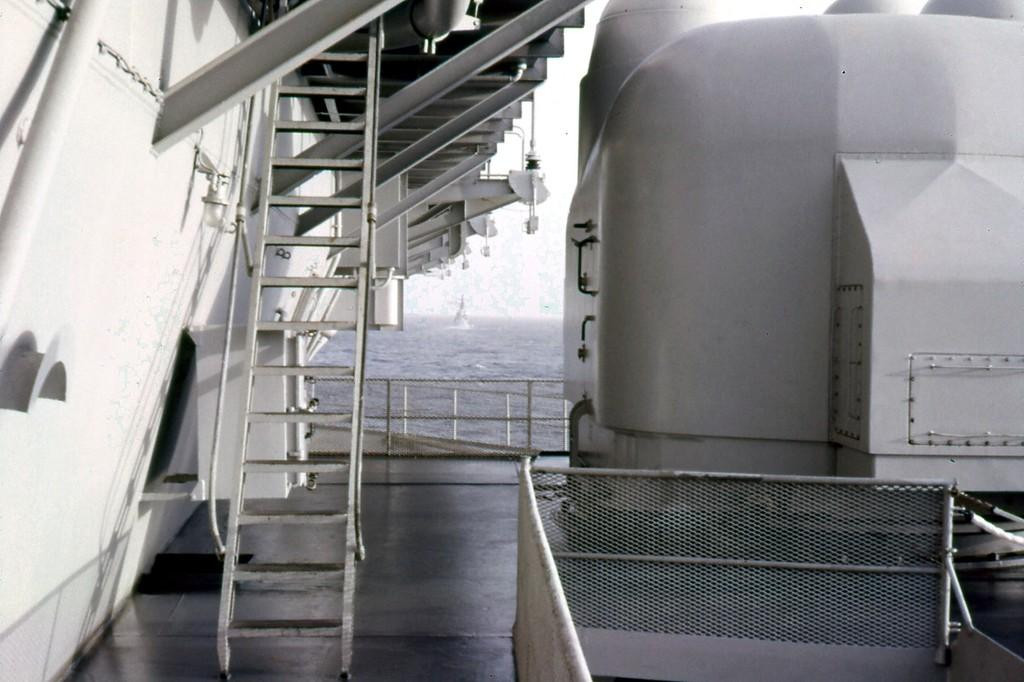What type of structure is present in the image? There is a staircase in the image. What feature is present alongside the staircase? There are railings in the image. What material are the grills in the image made of? The iron grills in the image are made of iron. What can be seen in the background of the image? The sky and water are visible in the image. How many bulbs are hanging from the ceiling in the image? There are no bulbs visible in the image. What type of hall is shown in the image? There is no hall present in the image; it features a staircase, railings, iron grills, and a background with sky and water. Is there a boot visible in the image? There is no boot present in the image. 